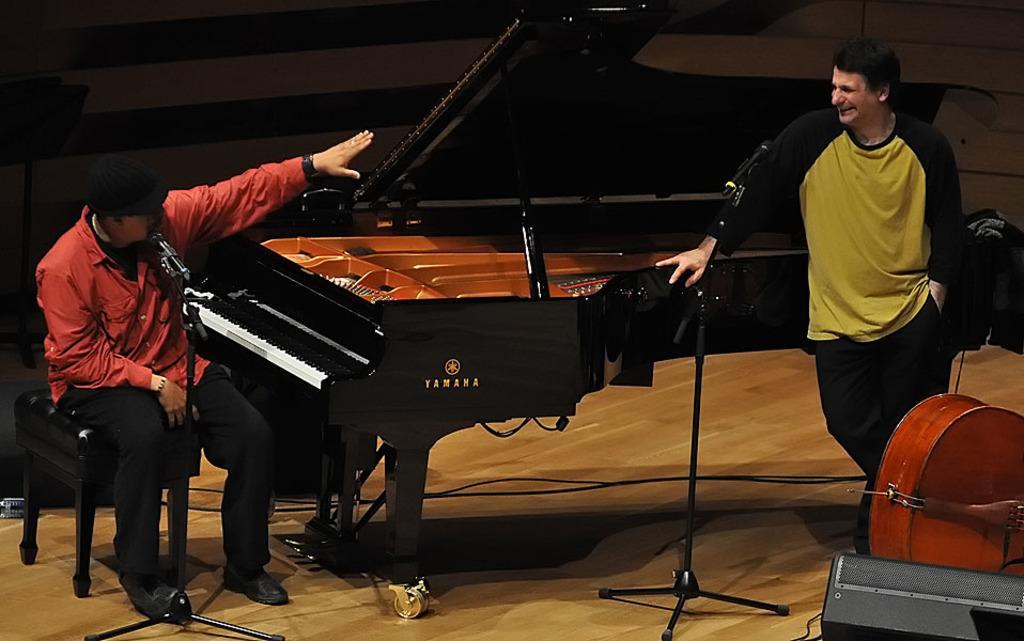Please provide a concise description of this image. In this image, there is a person on the left of the image sitting on chair in front of the mic. This person is wearing clothes and footwear. There is an another person on the right side of the image standing and wearing clothes. There is a piano in the center of the image. There is a drum and speaker in the bottom right of the image. 